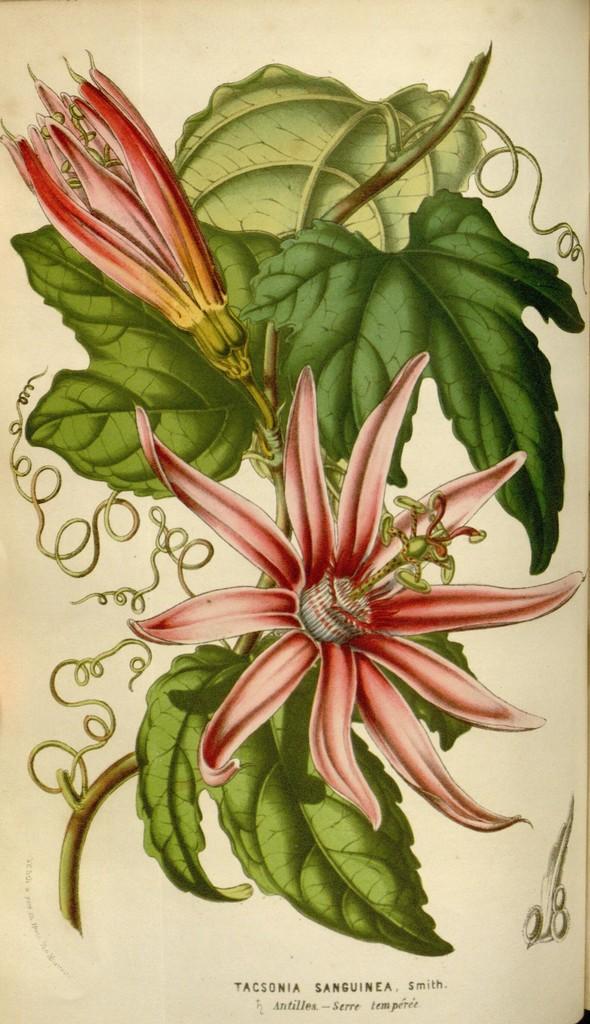Could you give a brief overview of what you see in this image? In this image we can see the painted picture. In this picture there is some text on the bottom of the image, some design on the bottom right side of the image, two flowers with leaves and stems. 